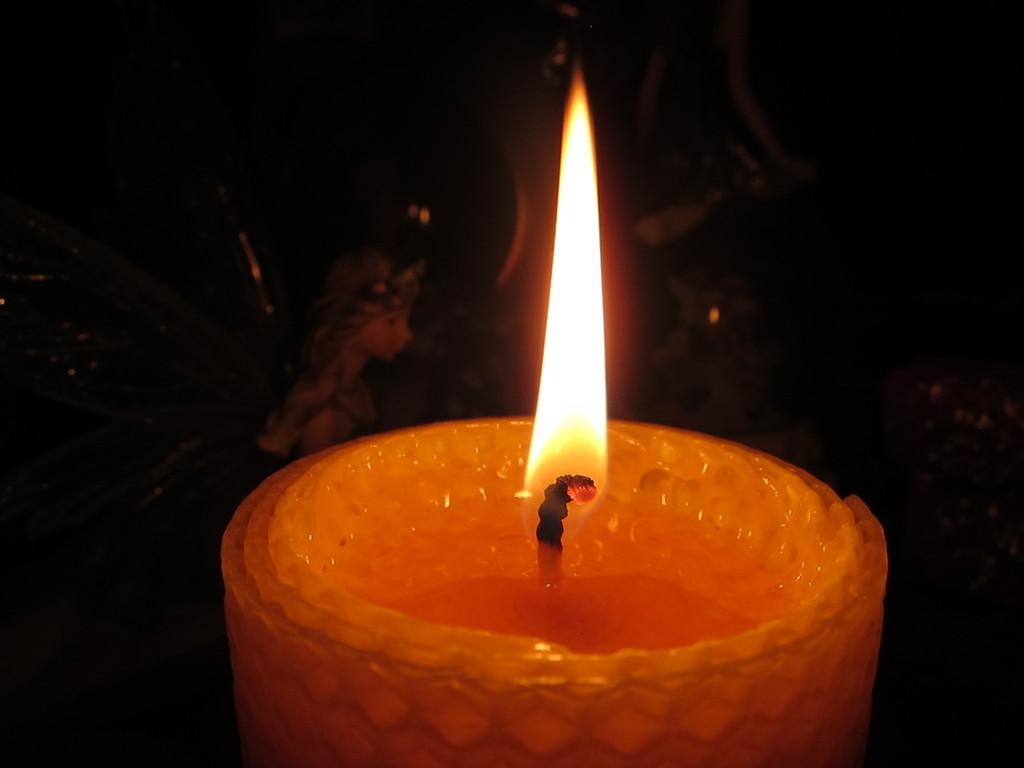What object can be seen in the image that provides light? There is a candle in the image that provides light. What other object is present in the image? There is a doll in the image. Can you describe the overall appearance of the image? The background of the image is dark. What type of lamp is being used by the grandmother in the image? There is no lamp or grandmother present in the image. 